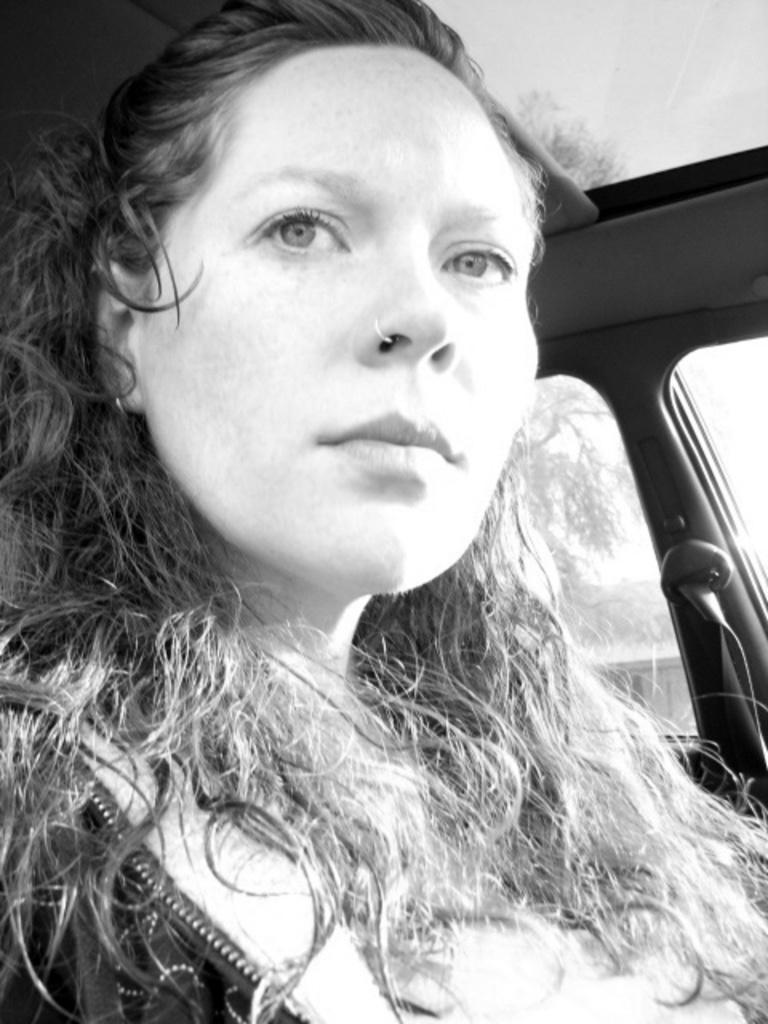What is the color scheme of the image? The image is black and white. What can be seen in the image? There is a woman sitting in the image. Can you describe the setting of the image? The image may have been taken inside a vehicle. How many spiders are crawling on the woman's head in the image? There are no spiders present in the image. What type of nut is the woman holding in the image? There is no nut visible in the image. 